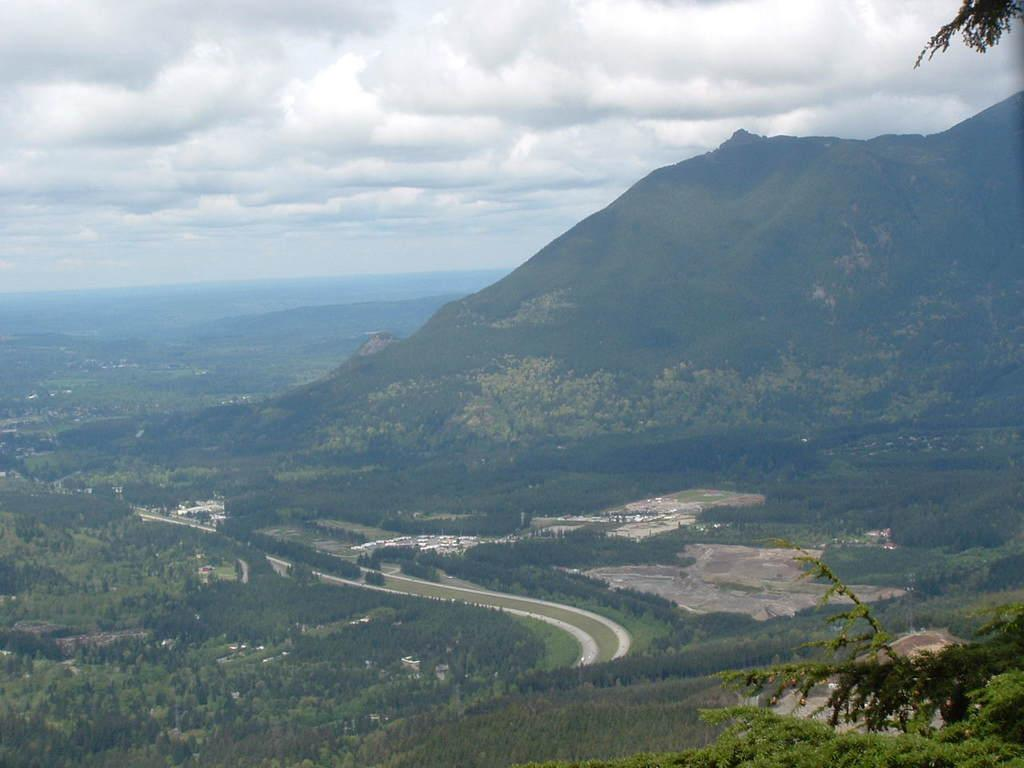What type of vegetation can be seen in the image? There are trees and plants in the image. What type of landscape feature is present in the image? There are hills in the image. What can be seen in the background of the image? The sky is visible in the background of the image. How many zebras can be seen swimming in the image? There are no zebras or bodies of water present in the image, so it is not possible to see any swimming zebras. 